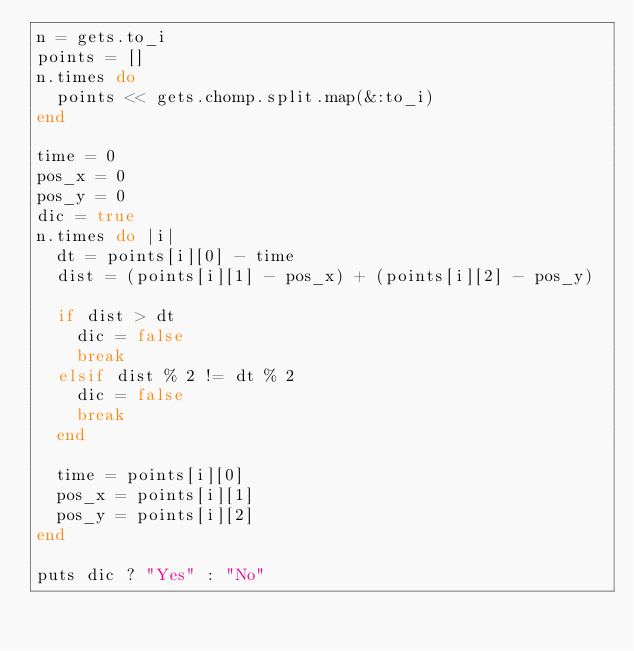<code> <loc_0><loc_0><loc_500><loc_500><_Ruby_>n = gets.to_i
points = []
n.times do
  points << gets.chomp.split.map(&:to_i)
end

time = 0
pos_x = 0
pos_y = 0
dic = true
n.times do |i|
  dt = points[i][0] - time
  dist = (points[i][1] - pos_x) + (points[i][2] - pos_y)

  if dist > dt
    dic = false
    break
  elsif dist % 2 != dt % 2
    dic = false
    break
  end

  time = points[i][0]
  pos_x = points[i][1]
  pos_y = points[i][2]
end

puts dic ? "Yes" : "No"</code> 